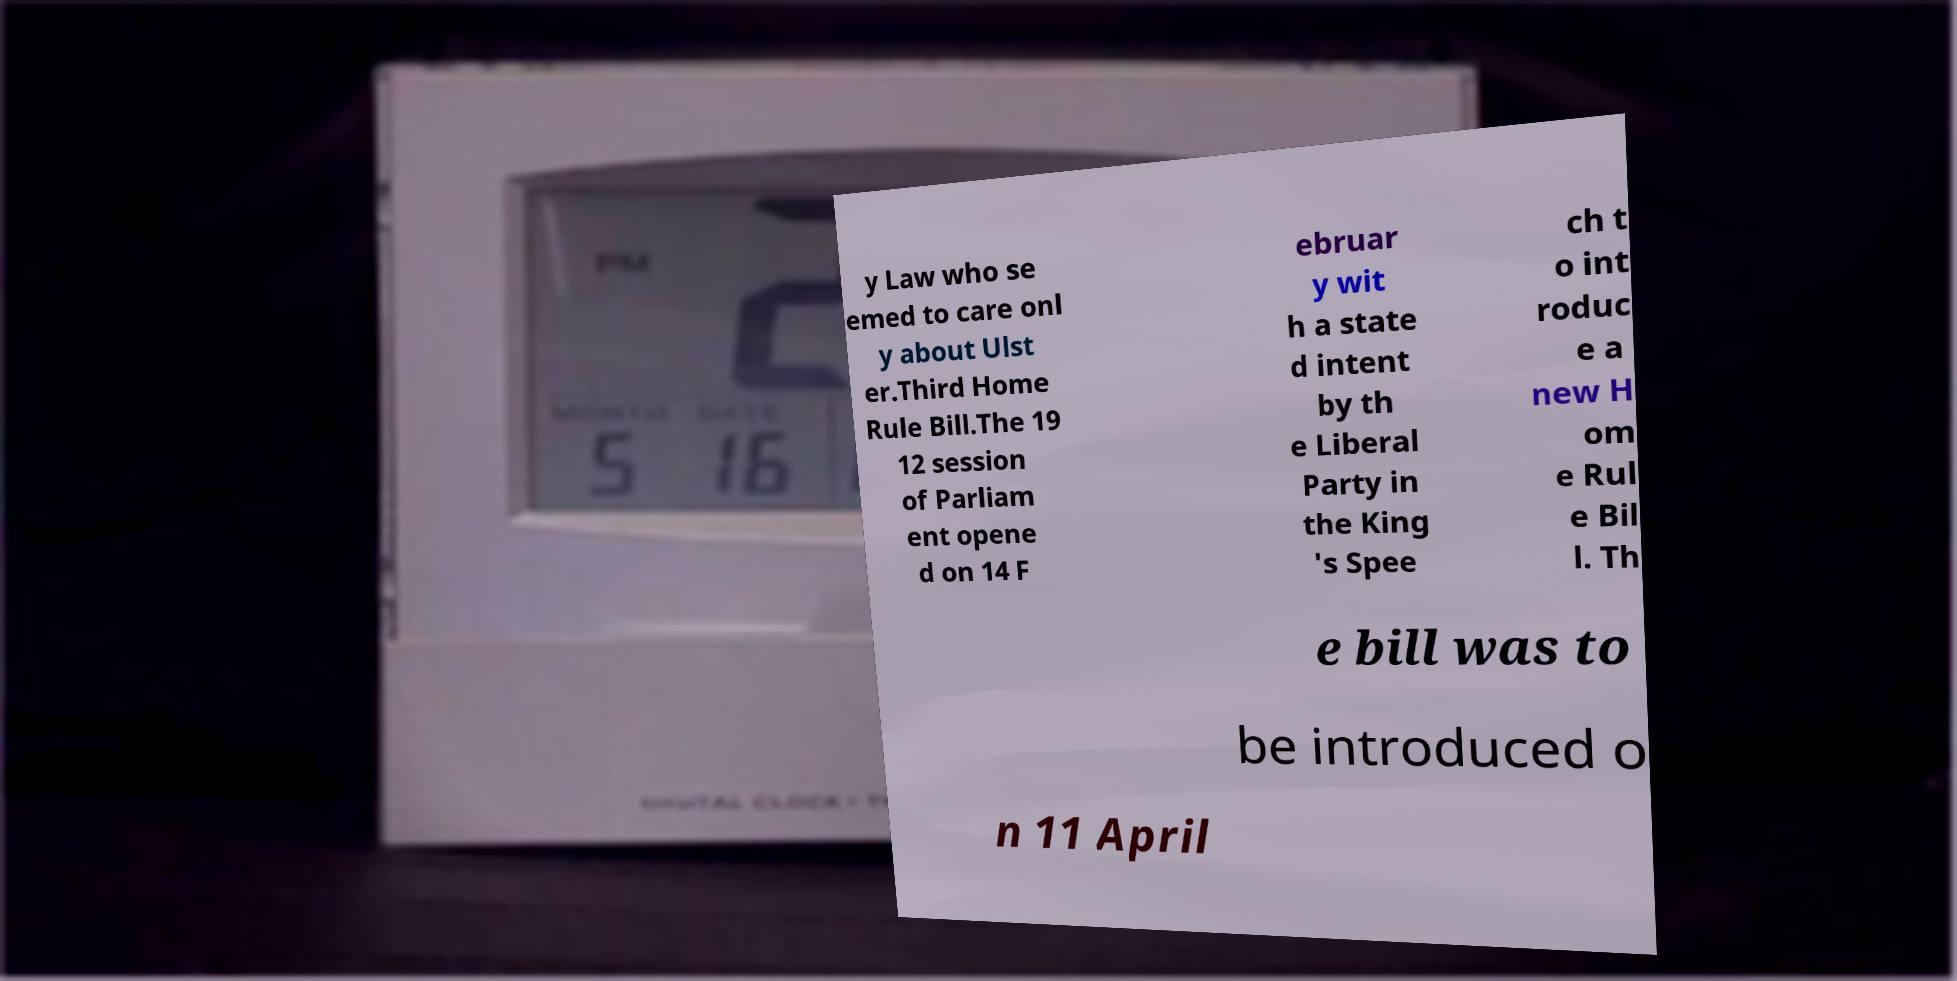For documentation purposes, I need the text within this image transcribed. Could you provide that? y Law who se emed to care onl y about Ulst er.Third Home Rule Bill.The 19 12 session of Parliam ent opene d on 14 F ebruar y wit h a state d intent by th e Liberal Party in the King 's Spee ch t o int roduc e a new H om e Rul e Bil l. Th e bill was to be introduced o n 11 April 